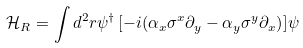Convert formula to latex. <formula><loc_0><loc_0><loc_500><loc_500>\mathcal { H } _ { R } = \int d ^ { 2 } { r } \psi ^ { \dagger } \left [ - i ( \alpha _ { x } \sigma ^ { x } \partial _ { y } - \alpha _ { y } \sigma ^ { y } \partial _ { x } \right ) ] \psi</formula> 